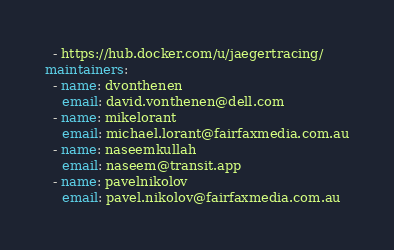Convert code to text. <code><loc_0><loc_0><loc_500><loc_500><_YAML_>  - https://hub.docker.com/u/jaegertracing/
maintainers:
  - name: dvonthenen
    email: david.vonthenen@dell.com
  - name: mikelorant
    email: michael.lorant@fairfaxmedia.com.au
  - name: naseemkullah
    email: naseem@transit.app
  - name: pavelnikolov
    email: pavel.nikolov@fairfaxmedia.com.au
</code> 